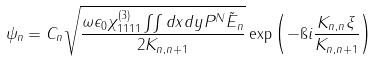<formula> <loc_0><loc_0><loc_500><loc_500>\psi _ { n } = C _ { n } \sqrt { \frac { \omega \epsilon _ { 0 } \chi ^ { ( 3 ) } _ { 1 1 1 1 } \iint d x d y P ^ { N } \tilde { E } _ { n } } { 2 K _ { n , n + 1 } } } \exp \left ( - \i i \frac { K _ { n , n } \xi } { K _ { n , n + 1 } } \right )</formula> 